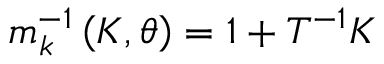Convert formula to latex. <formula><loc_0><loc_0><loc_500><loc_500>m _ { k } ^ { - 1 } \left ( K , \theta \right ) = 1 + T ^ { - 1 } K</formula> 